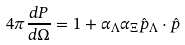Convert formula to latex. <formula><loc_0><loc_0><loc_500><loc_500>4 \pi \frac { d P } { d \Omega } = 1 + \alpha _ { \Lambda } \alpha _ { \Xi } \hat { p } _ { \Lambda } \cdot \hat { p }</formula> 